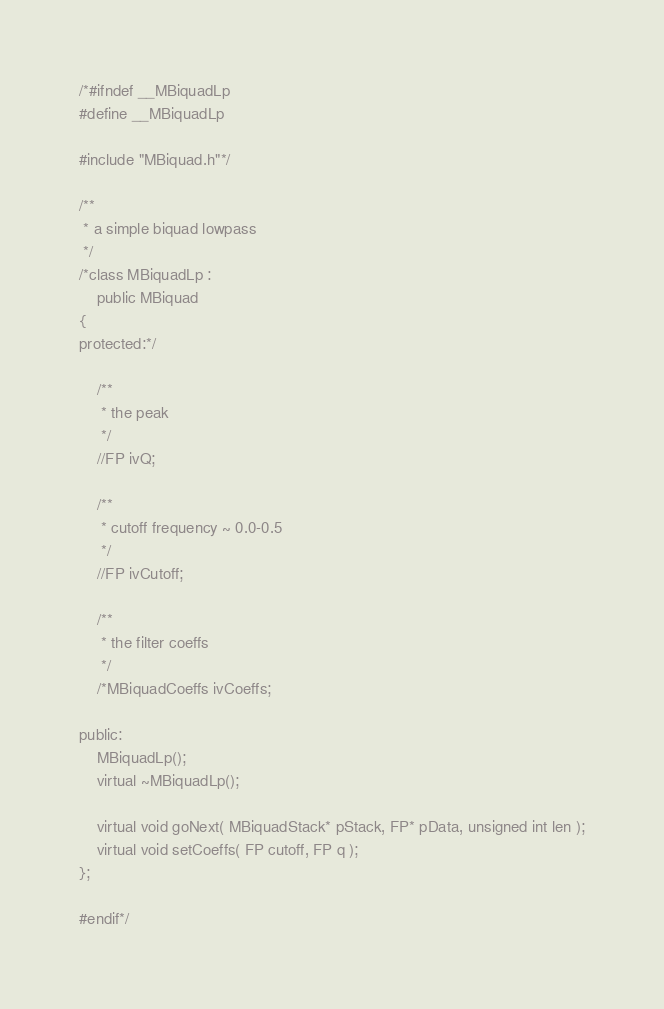<code> <loc_0><loc_0><loc_500><loc_500><_C_>/*#ifndef __MBiquadLp
#define __MBiquadLp

#include "MBiquad.h"*/

/**
 * a simple biquad lowpass
 */
/*class MBiquadLp :
	public MBiquad
{
protected:*/

	/**
	 * the peak
	 */
	//FP ivQ;

	/** 
	 * cutoff frequency ~ 0.0-0.5
	 */
	//FP ivCutoff;

	/**
	 * the filter coeffs
	 */
	/*MBiquadCoeffs ivCoeffs;

public:
	MBiquadLp();
	virtual ~MBiquadLp();

	virtual void goNext( MBiquadStack* pStack, FP* pData, unsigned int len );
	virtual void setCoeffs( FP cutoff, FP q );
};

#endif*/</code> 